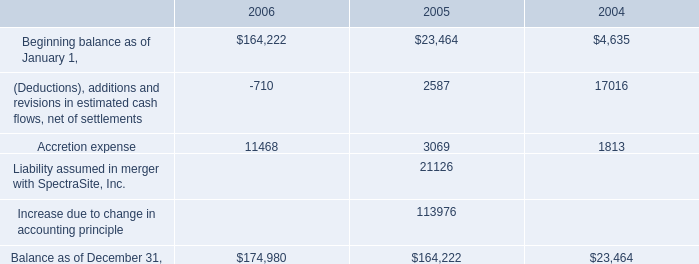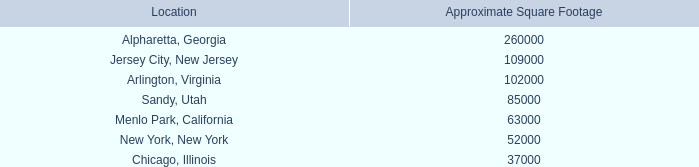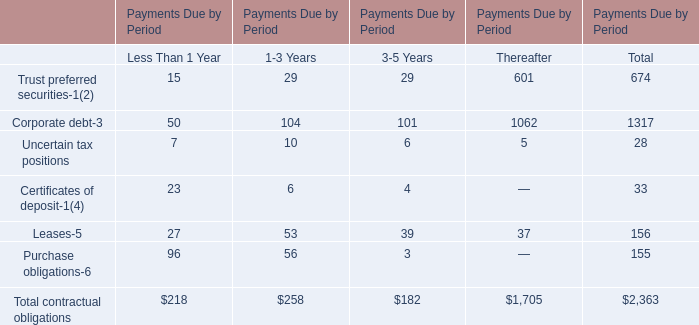What is the average amount of Arlington, Virginia of Approximate Square Footage, and Corporate debt of Payments Due by Period Thereafter ? 
Computations: ((102000.0 + 1062.0) / 2)
Answer: 51531.0. 